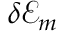<formula> <loc_0><loc_0><loc_500><loc_500>\delta \mathcal { E } _ { m }</formula> 